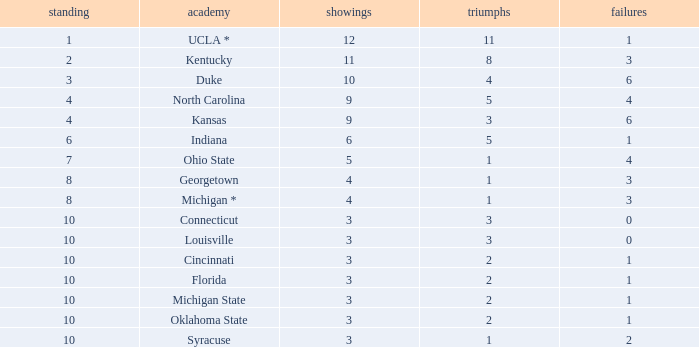Could you help me parse every detail presented in this table? {'header': ['standing', 'academy', 'showings', 'triumphs', 'failures'], 'rows': [['1', 'UCLA *', '12', '11', '1'], ['2', 'Kentucky', '11', '8', '3'], ['3', 'Duke', '10', '4', '6'], ['4', 'North Carolina', '9', '5', '4'], ['4', 'Kansas', '9', '3', '6'], ['6', 'Indiana', '6', '5', '1'], ['7', 'Ohio State', '5', '1', '4'], ['8', 'Georgetown', '4', '1', '3'], ['8', 'Michigan *', '4', '1', '3'], ['10', 'Connecticut', '3', '3', '0'], ['10', 'Louisville', '3', '3', '0'], ['10', 'Cincinnati', '3', '2', '1'], ['10', 'Florida', '3', '2', '1'], ['10', 'Michigan State', '3', '2', '1'], ['10', 'Oklahoma State', '3', '2', '1'], ['10', 'Syracuse', '3', '1', '2']]} Tell me the average Rank for lossess less than 6 and wins less than 11 for michigan state 10.0. 